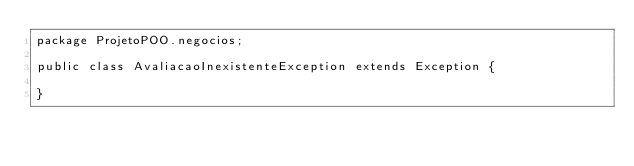<code> <loc_0><loc_0><loc_500><loc_500><_Java_>package ProjetoPOO.negocios;

public class AvaliacaoInexistenteException extends Exception {

}
</code> 